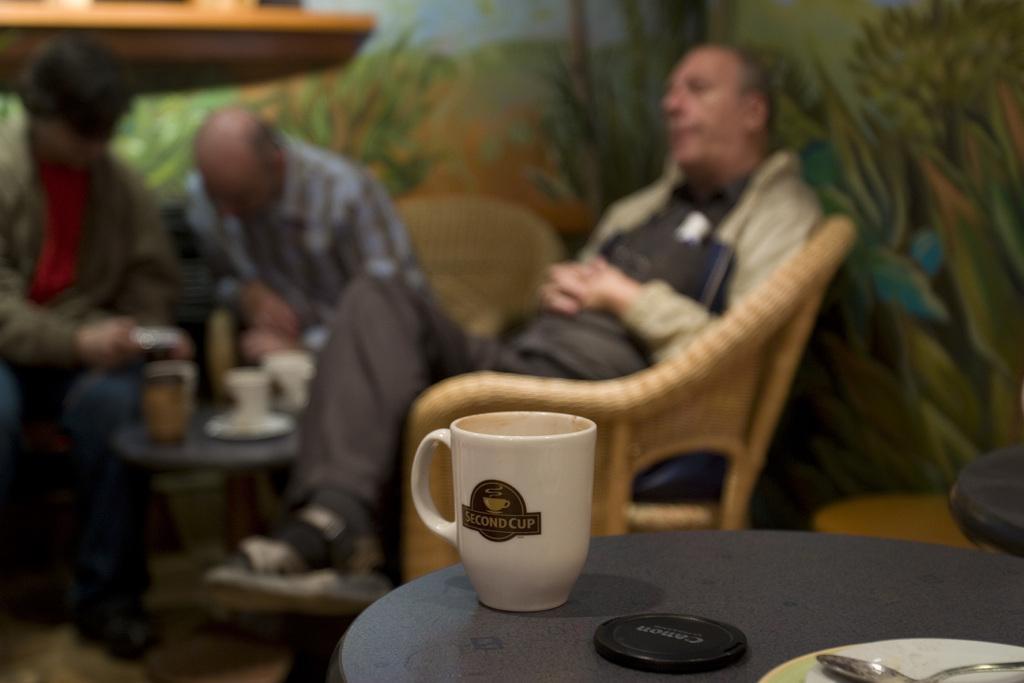Could you give a brief overview of what you see in this image? In this image there is a coffee cup on the table and lens cap and at the background there are three persons sitting on the chairs. 